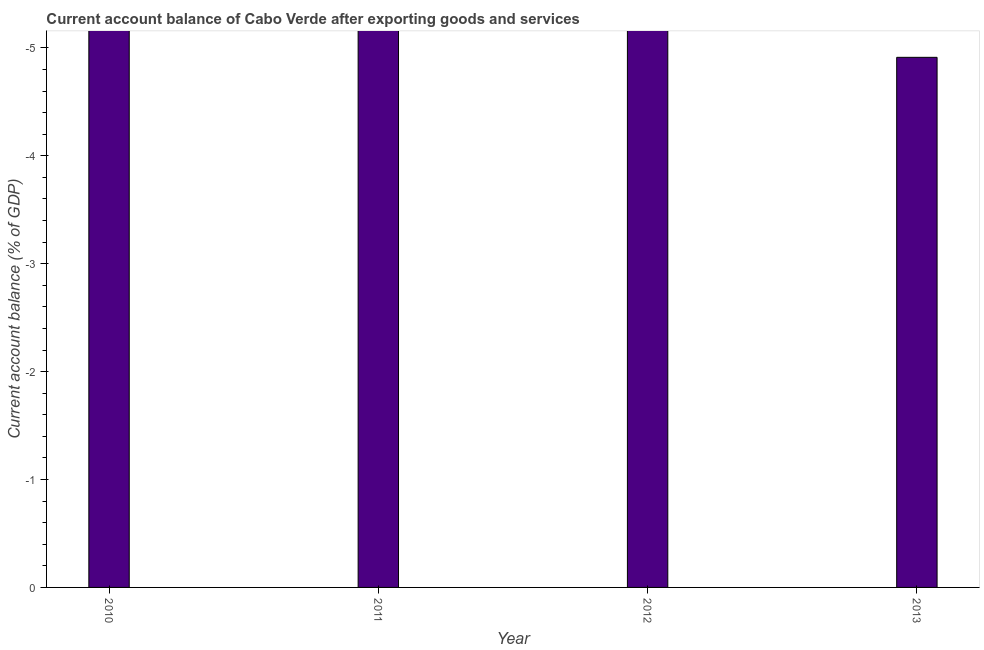Does the graph contain grids?
Your answer should be very brief. No. What is the title of the graph?
Give a very brief answer. Current account balance of Cabo Verde after exporting goods and services. What is the label or title of the X-axis?
Make the answer very short. Year. What is the label or title of the Y-axis?
Ensure brevity in your answer.  Current account balance (% of GDP). What is the sum of the current account balance?
Give a very brief answer. 0. What is the median current account balance?
Ensure brevity in your answer.  0. In how many years, is the current account balance greater than -0.6 %?
Your answer should be compact. 0. In how many years, is the current account balance greater than the average current account balance taken over all years?
Keep it short and to the point. 0. How many bars are there?
Provide a succinct answer. 0. How many years are there in the graph?
Keep it short and to the point. 4. What is the Current account balance (% of GDP) in 2010?
Provide a short and direct response. 0. What is the Current account balance (% of GDP) of 2011?
Ensure brevity in your answer.  0. What is the Current account balance (% of GDP) in 2012?
Provide a short and direct response. 0. What is the Current account balance (% of GDP) of 2013?
Keep it short and to the point. 0. 